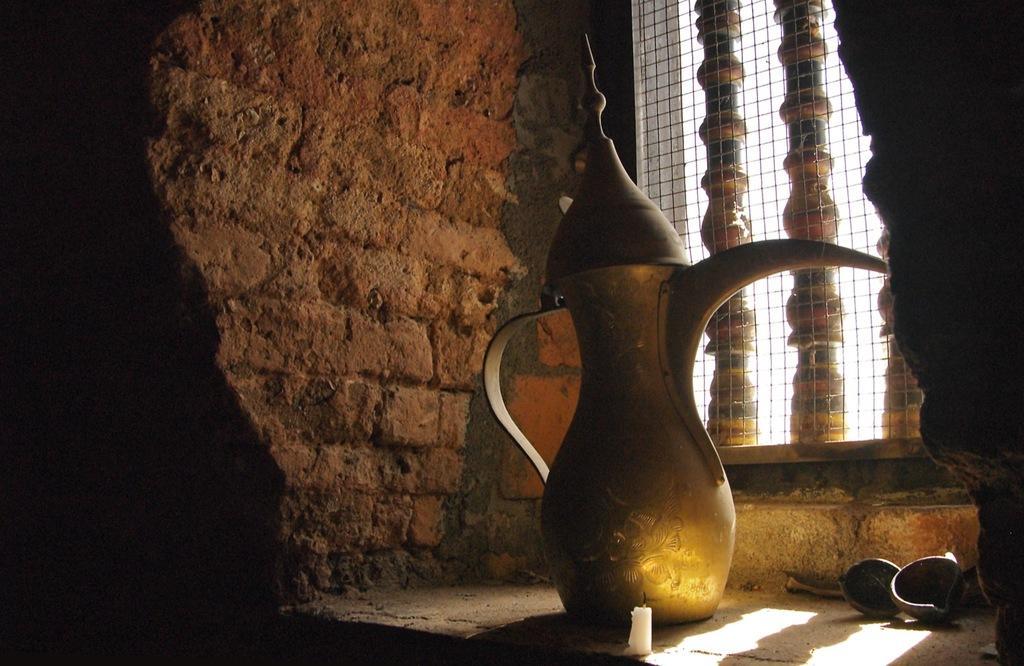Can you describe this image briefly? In this image there is a copper jug, diyas, candle and at the background there is a wall, iron net. 